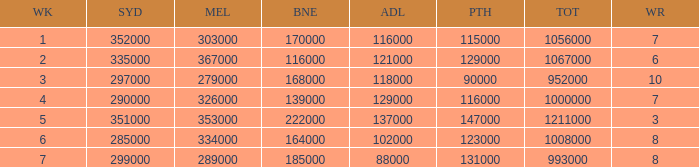Can you give me this table as a dict? {'header': ['WK', 'SYD', 'MEL', 'BNE', 'ADL', 'PTH', 'TOT', 'WR'], 'rows': [['1', '352000', '303000', '170000', '116000', '115000', '1056000', '7'], ['2', '335000', '367000', '116000', '121000', '129000', '1067000', '6'], ['3', '297000', '279000', '168000', '118000', '90000', '952000', '10'], ['4', '290000', '326000', '139000', '129000', '116000', '1000000', '7'], ['5', '351000', '353000', '222000', '137000', '147000', '1211000', '3'], ['6', '285000', '334000', '164000', '102000', '123000', '1008000', '8'], ['7', '299000', '289000', '185000', '88000', '131000', '993000', '8']]} What is the highest number of Brisbane viewers? 222000.0. 